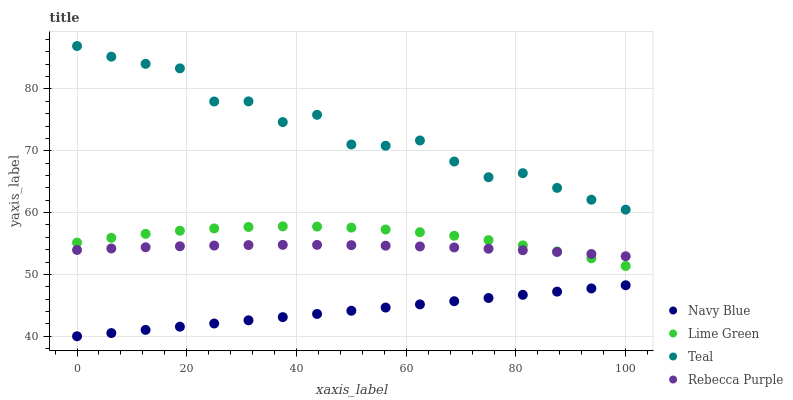Does Navy Blue have the minimum area under the curve?
Answer yes or no. Yes. Does Teal have the maximum area under the curve?
Answer yes or no. Yes. Does Lime Green have the minimum area under the curve?
Answer yes or no. No. Does Lime Green have the maximum area under the curve?
Answer yes or no. No. Is Navy Blue the smoothest?
Answer yes or no. Yes. Is Teal the roughest?
Answer yes or no. Yes. Is Lime Green the smoothest?
Answer yes or no. No. Is Lime Green the roughest?
Answer yes or no. No. Does Navy Blue have the lowest value?
Answer yes or no. Yes. Does Lime Green have the lowest value?
Answer yes or no. No. Does Teal have the highest value?
Answer yes or no. Yes. Does Lime Green have the highest value?
Answer yes or no. No. Is Lime Green less than Teal?
Answer yes or no. Yes. Is Teal greater than Rebecca Purple?
Answer yes or no. Yes. Does Rebecca Purple intersect Lime Green?
Answer yes or no. Yes. Is Rebecca Purple less than Lime Green?
Answer yes or no. No. Is Rebecca Purple greater than Lime Green?
Answer yes or no. No. Does Lime Green intersect Teal?
Answer yes or no. No. 